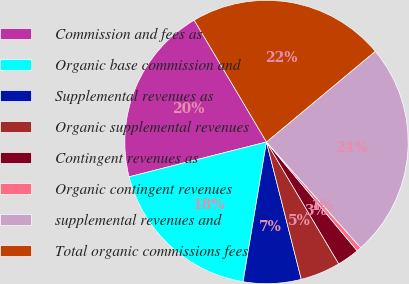Convert chart to OTSL. <chart><loc_0><loc_0><loc_500><loc_500><pie_chart><fcel>Commission and fees as<fcel>Organic base commission and<fcel>Supplemental revenues as<fcel>Organic supplemental revenues<fcel>Contingent revenues as<fcel>Organic contingent revenues<fcel>supplemental revenues and<fcel>Total organic commissions fees<nl><fcel>20.43%<fcel>18.41%<fcel>6.59%<fcel>4.57%<fcel>2.54%<fcel>0.52%<fcel>24.48%<fcel>22.46%<nl></chart> 